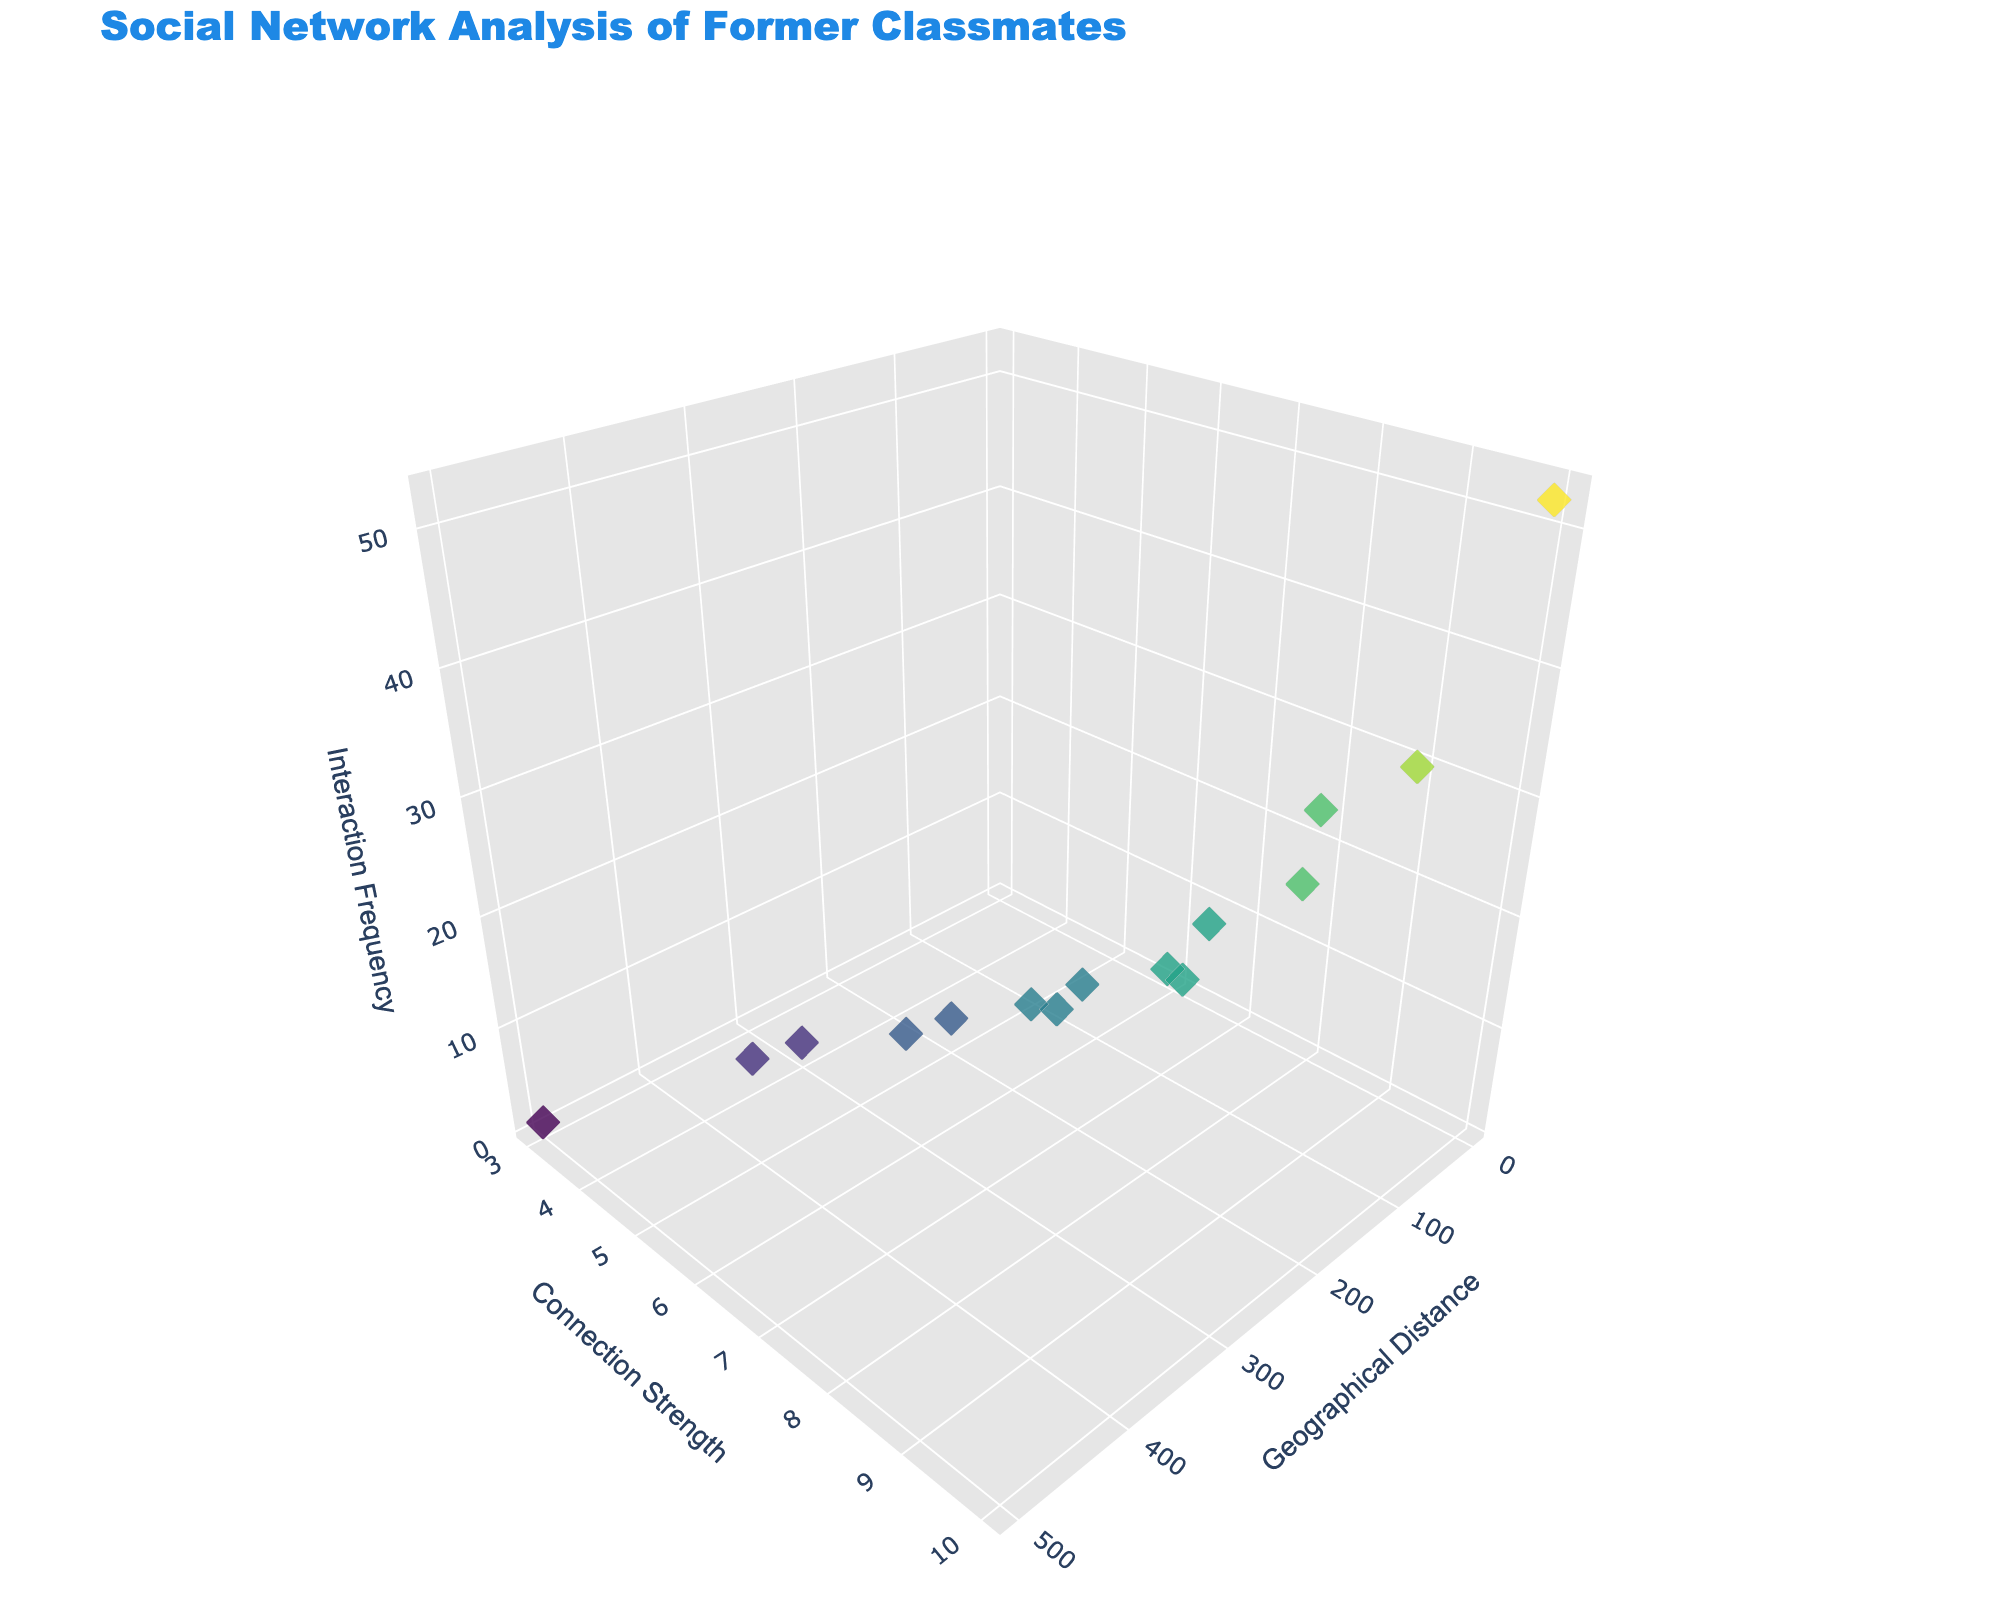What is the title of the figure? The title is located at the top of the figure and is styled with a specific font size and color.
Answer: Social Network Analysis of Former Classmates How many data points are there in the plot? Each data point represents one individual from the dataset and is rendered as a symbol on the scatter plot. Counting each point will provide the total number.
Answer: 15 Which person has the highest Interaction Frequency? By examining the z-axis and identifying the point with the highest value, we can determine the individual with the highest Interaction Frequency. Josephine B. Daviau is at the topmost point with an Interaction Frequency of 52.
Answer: Josephine B. Daviau What are the axis titles in the 3D scatter plot? Axis titles can be found alongside each axis, indicating what each dimension represents. The titles for the plot are 'Geographical Distance', 'Connection Strength', and 'Interaction Frequency'.
Answer: Geographical Distance, Connection Strength, Interaction Frequency Which two individuals have the lowest Connection Strength, and what are their values? By identifying the points at the lowest position on the y-axis and checking their values, we can determine that Daniel H. Thompson and Jonathan B. Takahashi have the lowest Connection Strength of 4 and 3, respectively.
Answer: Daniel H. Thompson: 4, Jonathan B. Takahashi: 3 Compare the Interaction Frequency of Josephine B. Daviau and David K. Patel. Who interacts more frequently, and by how much? Josephine B. Daviau has an Interaction Frequency of 52, while David K. Patel has 6. The difference in their interaction frequencies is 52 - 6 = 46.
Answer: Josephine B. Daviau, by 46 Which person has the greatest Geographical Distance and what is their Connection Strength? Finding the point farthest along the x-axis shows that Jonathan B. Takahashi has the greatest Geographical Distance of 500. Looking at this point's y-value shows that his Connection Strength is 3.
Answer: Jonathan B. Takahashi, 3 What is the average Geographical Distance of the classmates whose Connection Strength is 8? The classmates with a Connection Strength of 8 are Michael T. Reynolds (15), Sophia G. Chen (30). The average Geographical Distance is (15 + 30) / 2 = 22.5.
Answer: 22.5 Between Sarah L. Nguyen and Olivia R. Martinez, who has a higher Interaction Frequency and what are their Connection Strengths? Sarah L. Nguyen has an Interaction Frequency of 12 and Olivia R. Martinez has 8. Sarah interacts more frequently. Their Connection Strengths are 7 each.
Answer: Sarah L. Nguyen, both have 7 What is the median Connection Strength of all individuals? Sorting the Connection Strength values: 3, 4, 4, 5, 5, 5, 6, 6, 6, 7, 7, 7, 8, 8, 9, 10, the middle value (the 8th value in this sorted list) is 7.
Answer: 7 